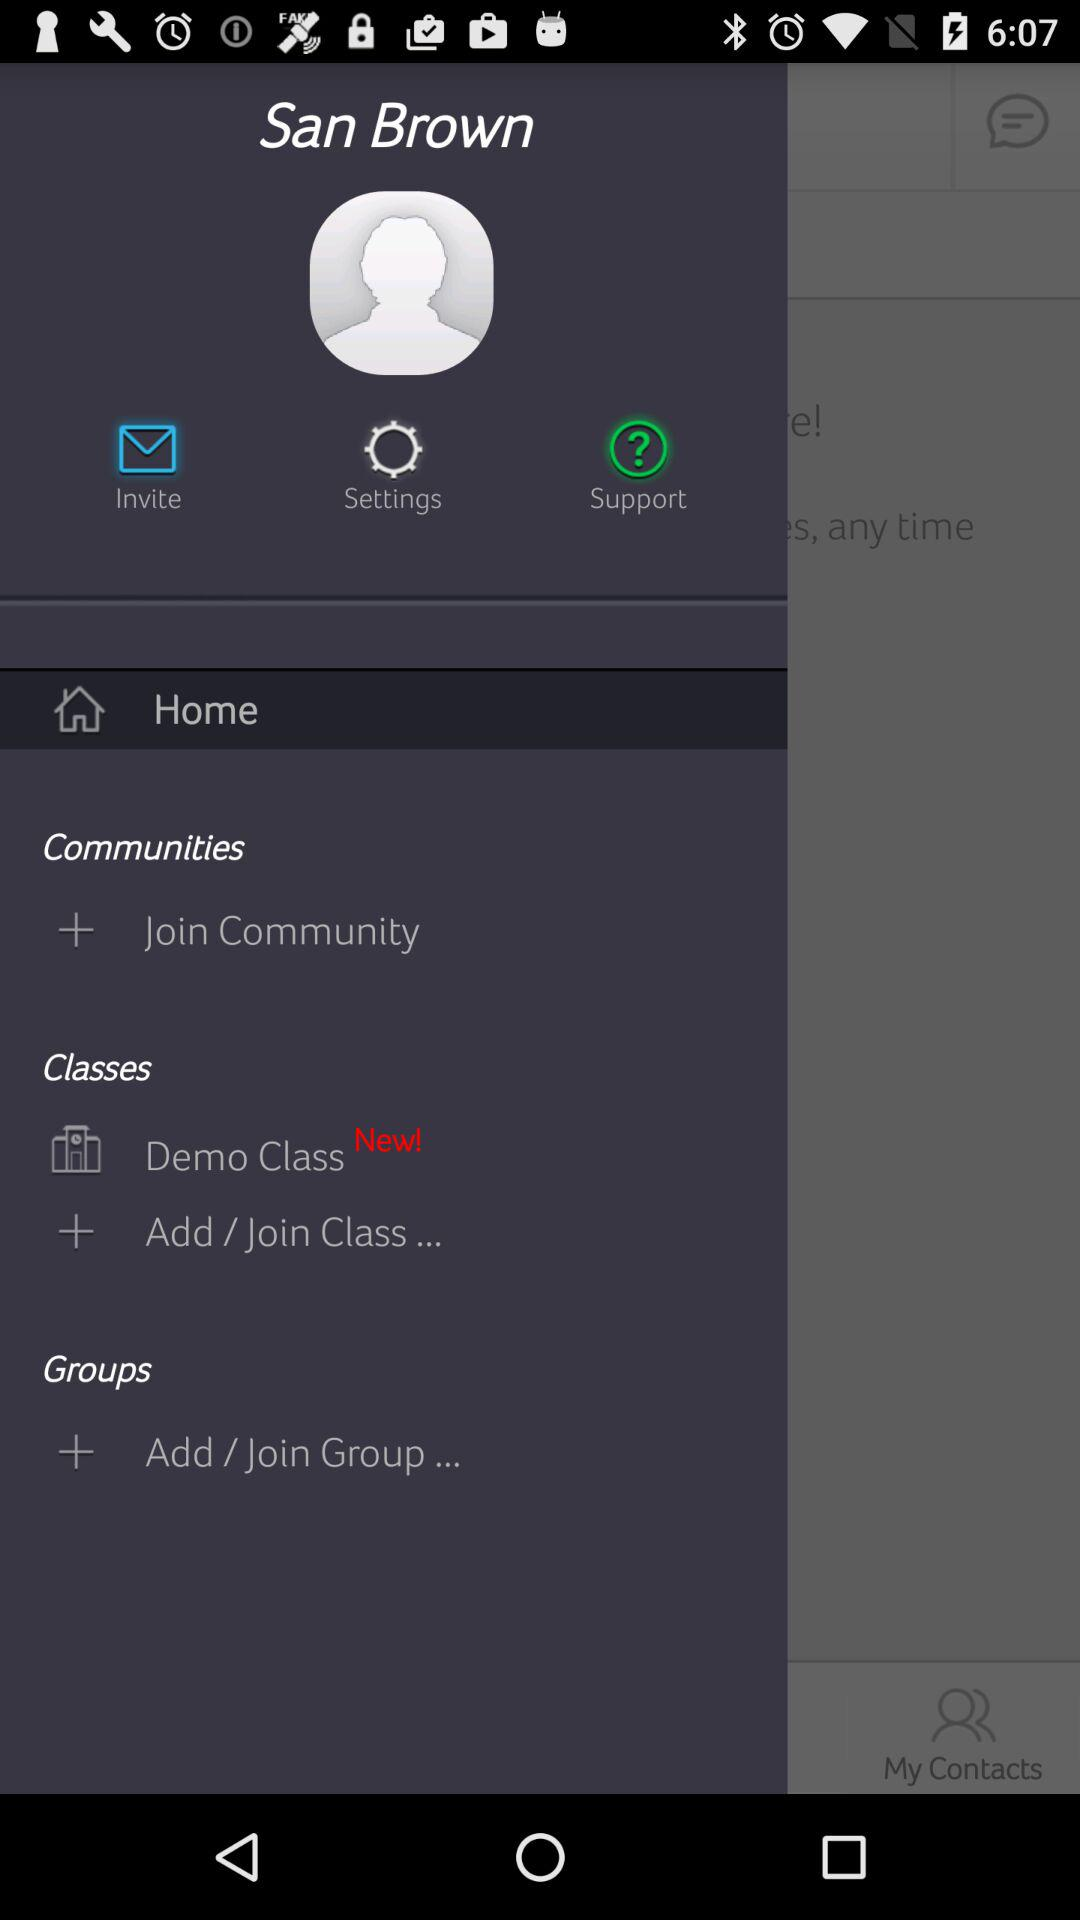What is the application name? The application name is "beta bloomz". 